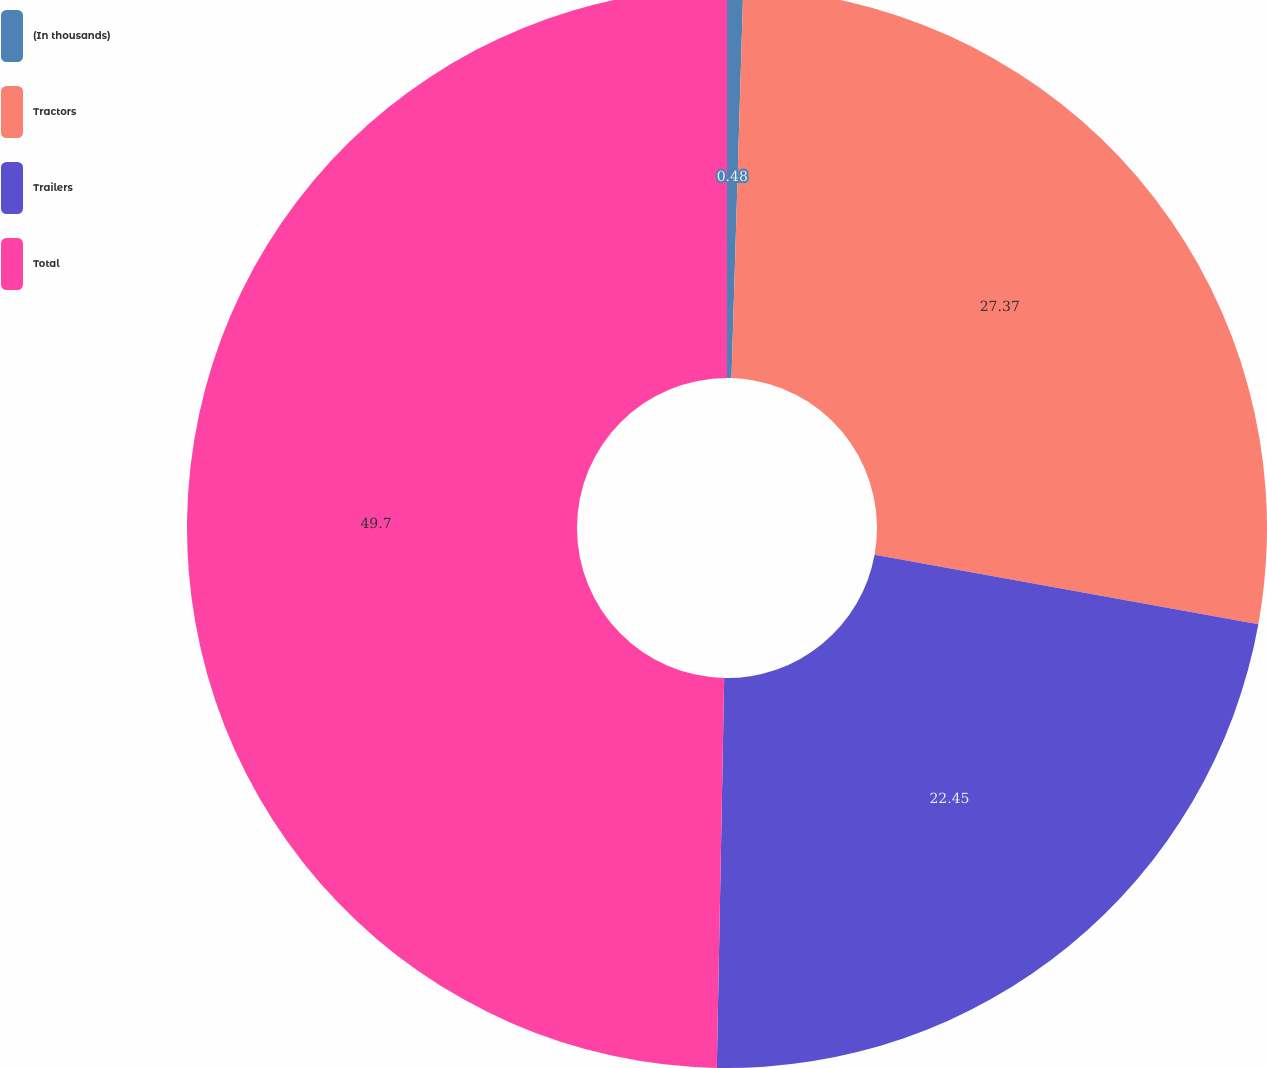Convert chart to OTSL. <chart><loc_0><loc_0><loc_500><loc_500><pie_chart><fcel>(In thousands)<fcel>Tractors<fcel>Trailers<fcel>Total<nl><fcel>0.48%<fcel>27.37%<fcel>22.45%<fcel>49.7%<nl></chart> 